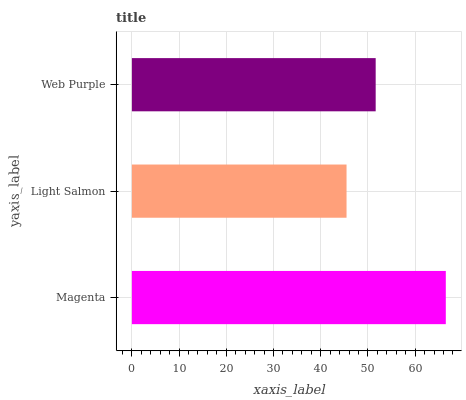Is Light Salmon the minimum?
Answer yes or no. Yes. Is Magenta the maximum?
Answer yes or no. Yes. Is Web Purple the minimum?
Answer yes or no. No. Is Web Purple the maximum?
Answer yes or no. No. Is Web Purple greater than Light Salmon?
Answer yes or no. Yes. Is Light Salmon less than Web Purple?
Answer yes or no. Yes. Is Light Salmon greater than Web Purple?
Answer yes or no. No. Is Web Purple less than Light Salmon?
Answer yes or no. No. Is Web Purple the high median?
Answer yes or no. Yes. Is Web Purple the low median?
Answer yes or no. Yes. Is Light Salmon the high median?
Answer yes or no. No. Is Light Salmon the low median?
Answer yes or no. No. 